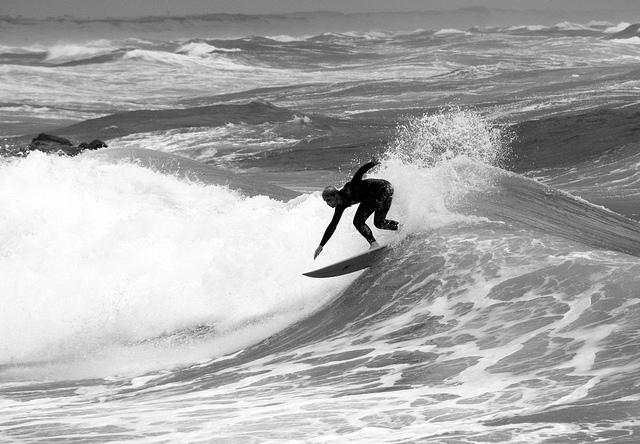What is this person doing?
Write a very short answer. Surfing. Is there a shark in the water?
Short answer required. No. Is the person wearing a wetsuit?
Answer briefly. Yes. 